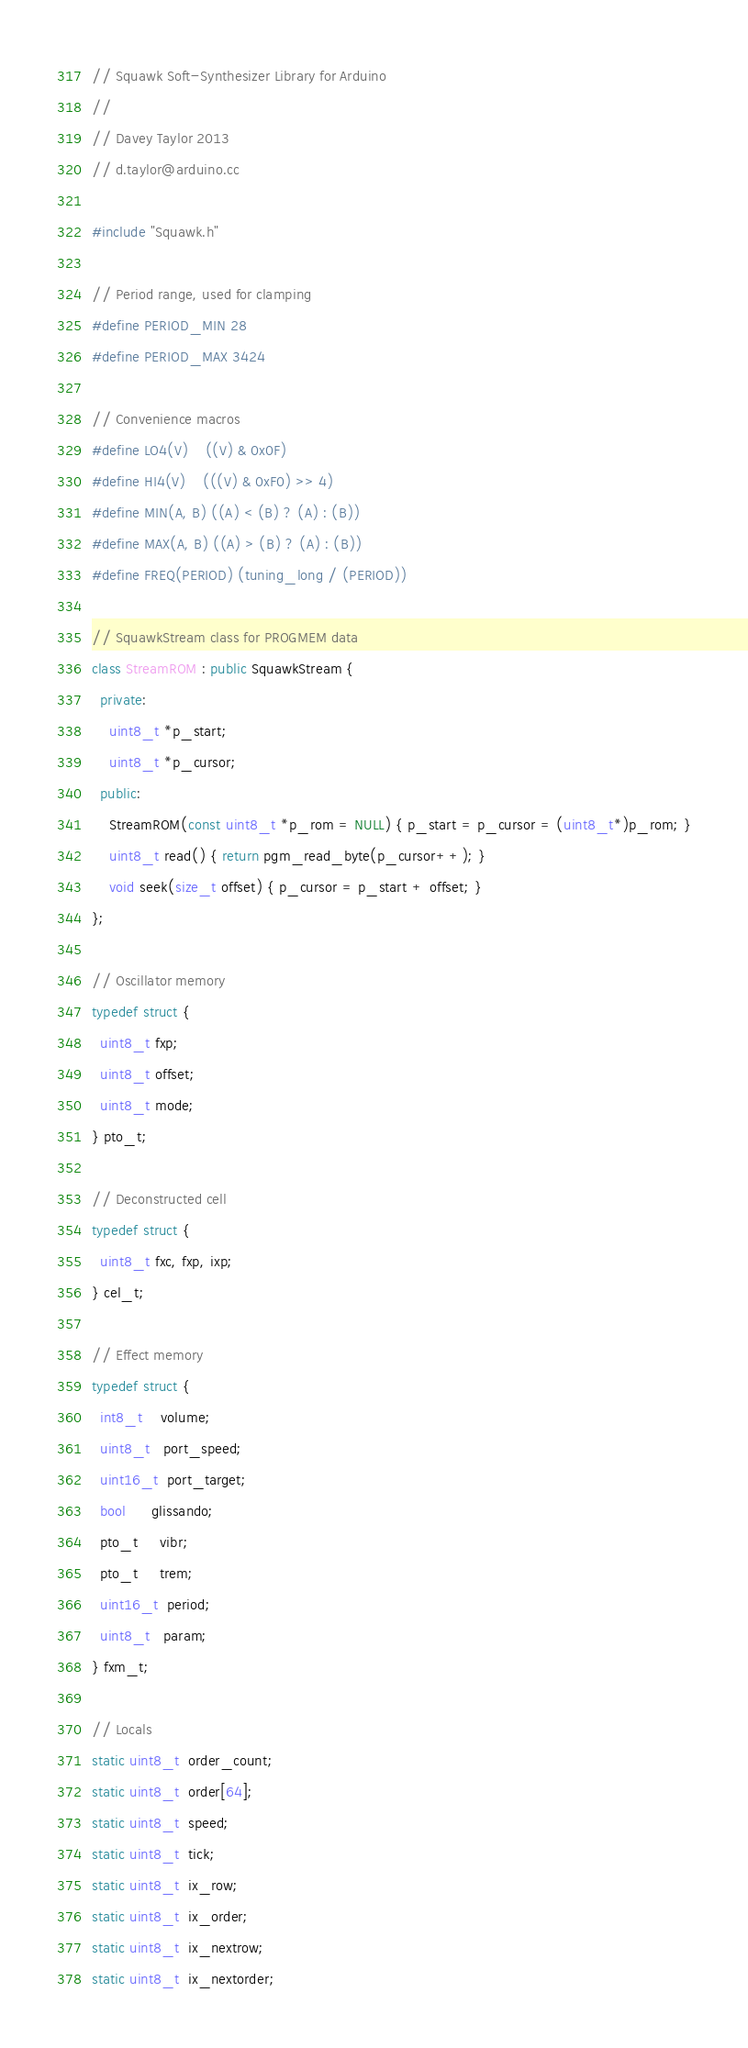Convert code to text. <code><loc_0><loc_0><loc_500><loc_500><_C++_>// Squawk Soft-Synthesizer Library for Arduino
//
// Davey Taylor 2013
// d.taylor@arduino.cc

#include "Squawk.h"

// Period range, used for clamping
#define PERIOD_MIN 28
#define PERIOD_MAX 3424

// Convenience macros
#define LO4(V)    ((V) & 0x0F)
#define HI4(V)    (((V) & 0xF0) >> 4)
#define MIN(A, B) ((A) < (B) ? (A) : (B))
#define MAX(A, B) ((A) > (B) ? (A) : (B))
#define FREQ(PERIOD) (tuning_long / (PERIOD))

// SquawkStream class for PROGMEM data
class StreamROM : public SquawkStream {
  private:
    uint8_t *p_start;
    uint8_t *p_cursor;
  public:
    StreamROM(const uint8_t *p_rom = NULL) { p_start = p_cursor = (uint8_t*)p_rom; }
    uint8_t read() { return pgm_read_byte(p_cursor++); }
    void seek(size_t offset) { p_cursor = p_start + offset; }
};

// Oscillator memory
typedef struct {
  uint8_t fxp;
  uint8_t offset;
  uint8_t mode;
} pto_t;

// Deconstructed cell
typedef struct {
  uint8_t fxc, fxp, ixp;
} cel_t;

// Effect memory
typedef struct {
  int8_t    volume;
  uint8_t   port_speed;
  uint16_t  port_target;
  bool      glissando;
  pto_t     vibr;
  pto_t     trem;
  uint16_t  period;
  uint8_t   param;
} fxm_t;

// Locals
static uint8_t  order_count;
static uint8_t  order[64];
static uint8_t  speed;
static uint8_t  tick;
static uint8_t  ix_row;
static uint8_t  ix_order;
static uint8_t  ix_nextrow;
static uint8_t  ix_nextorder;</code> 